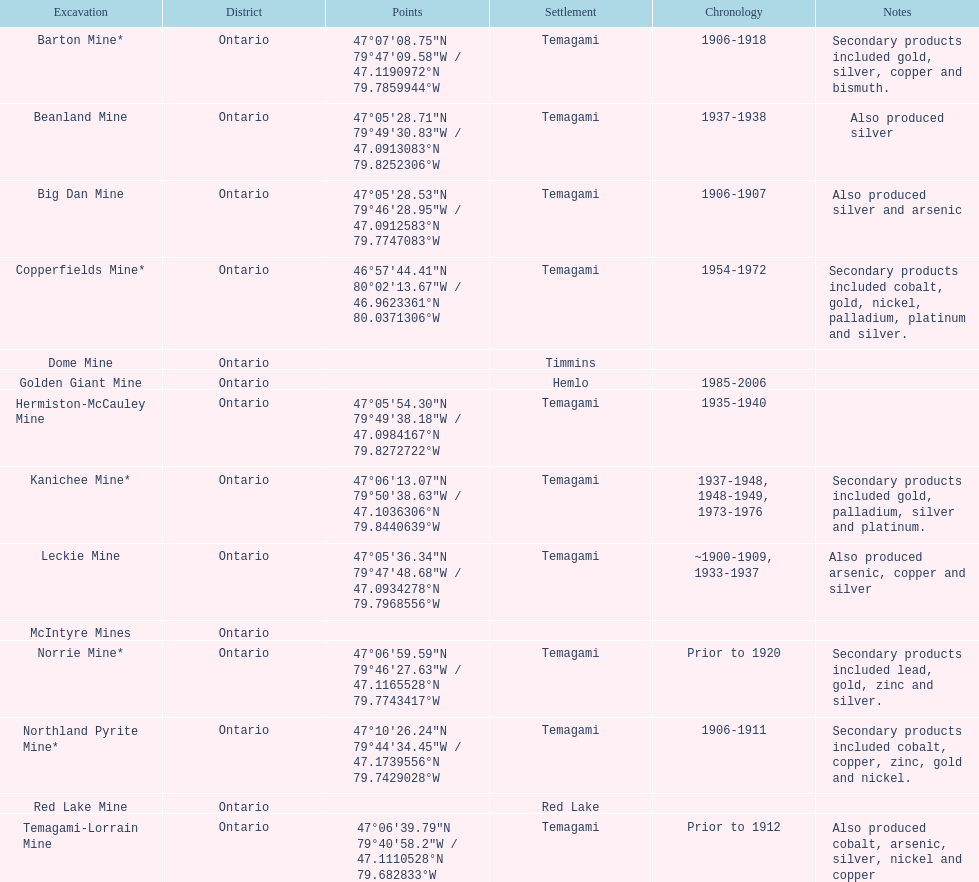Name a gold mine that was open at least 10 years. Barton Mine. 